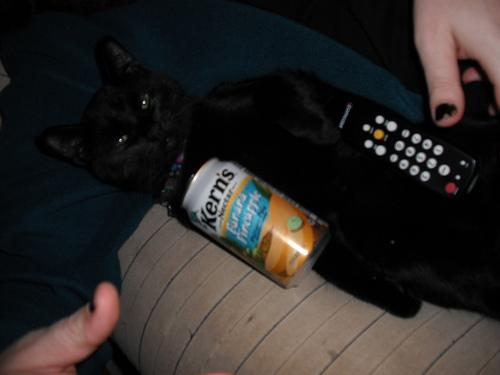The remote control placed on top of the black cat controls what object? television 